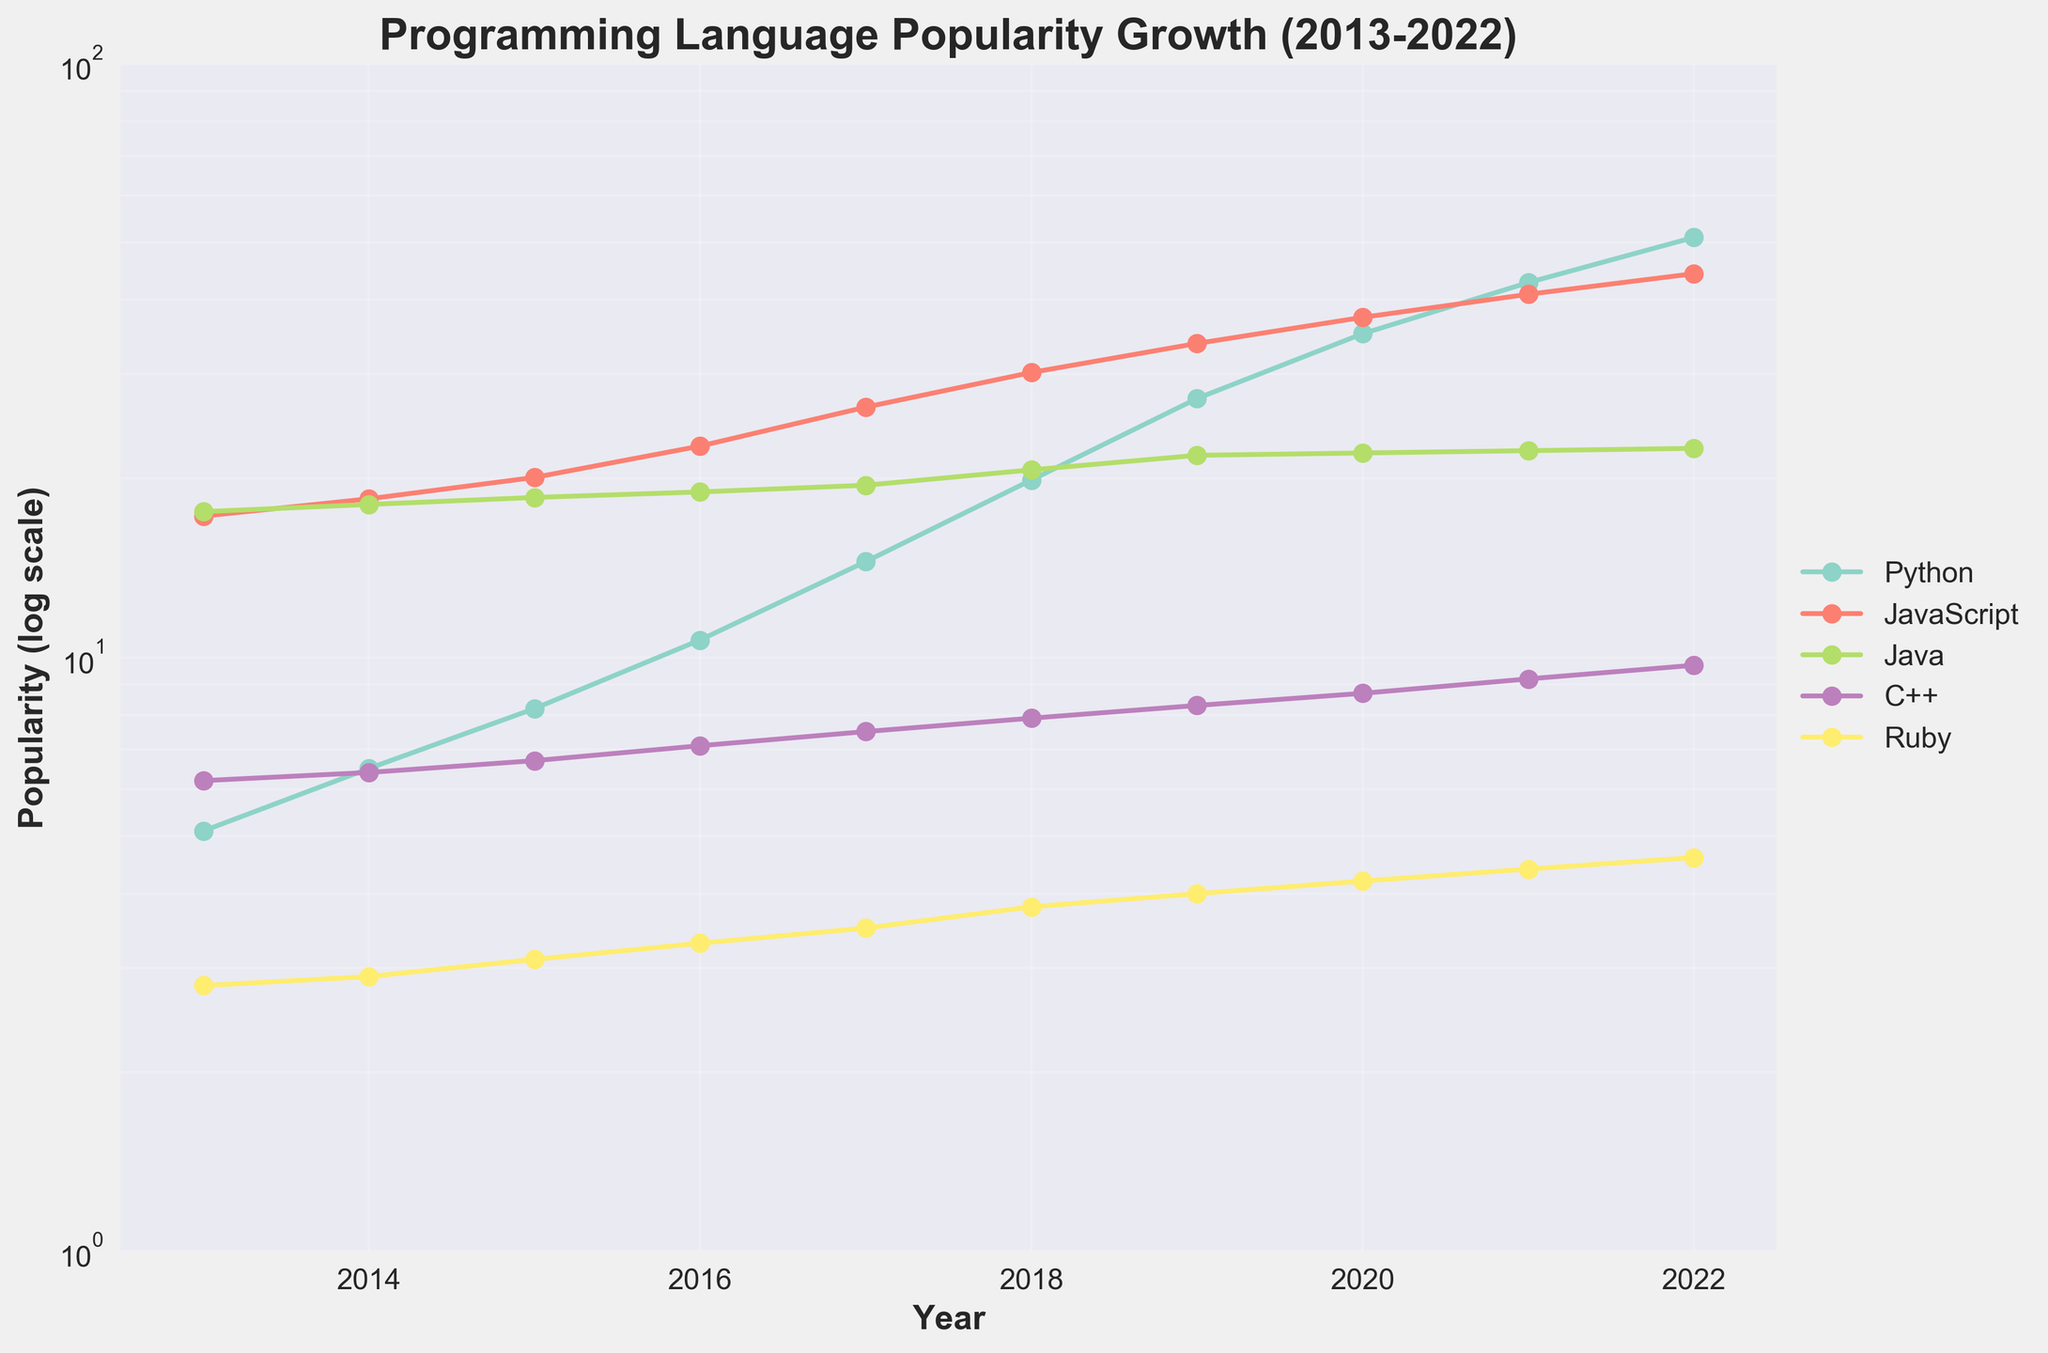What is the title of the plot? The title is typically displayed at the top of the figure. In this case, based on the code, the title is "Programming Language Popularity Growth (2013-2022)".
Answer: Programming Language Popularity Growth (2013-2022) Which language shows the highest popularity in 2022? To find the language with the highest popularity in 2022, look at the data points for each language in 2022. Python has a value of 51.0, which is higher than any other language in that year.
Answer: Python Which language shows the least change in popularity between 2013-2022? To identify the language with the least change in popularity, compare the difference in the popularity values between 2013 and 2022 for each language. Java shows the least change, with a change from 17.6 to 22.5.
Answer: Java How does the popularity of JavaScript change from 2013 to 2022? To describe the change, check the popularity values for JavaScript in 2013 and 2022: 17.3 in 2013 and 44.3 in 2022. The popularity of JavaScript increased over this period.
Answer: Increased What is the shape of the growth curve for Python? Observe the plot for Python across the years. The plot shows an exponential-like increase, indicating rapid growth over time.
Answer: Exponential-like Does Ruby ever surpass C++ in popularity during the decade? Compare the data points of Ruby and C++ for each year from 2013 to 2022. Ruby's popularity consistently remains below C++ throughout this period.
Answer: No Between which consecutive years did Python experience the most significant growth? Check the differences in Python's popularity values between consecutive years. The largest difference occurs between 2018 (19.9) and 2019 (27.3), with a change of 7.4.
Answer: 2018 and 2019 How does the popularity of C++ trend over the decade? Examine the data points for C++ from 2013 to 2022. The popularity shows a gradual increase from 6.2 to 9.7, indicating a steady upward trend.
Answer: Upward trend Which programming language has the steepest curve on the log scale plot? On a log scale, the steepest curve represents the language with the most rapid popularity growth. Python's curve is the steepest, indicating it had the fastest growth rate.
Answer: Python What is the median popularity of Java from 2013-2022? List Java’s popularity values from 2013 to 2022 (17.6, 18.1, 18.6, 19.0, 19.5, 20.7, 21.9, 22.1, 22.3, 22.5) in ascending order. The middle values are 19.5 and 20.7. The median is the average of these two values: (19.5 + 20.7) / 2 = 20.1.
Answer: 20.1 